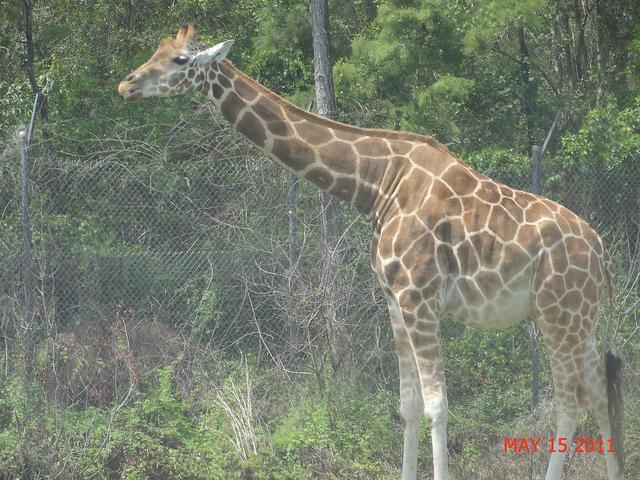How many different animals are shown?
Give a very brief answer. 1. 